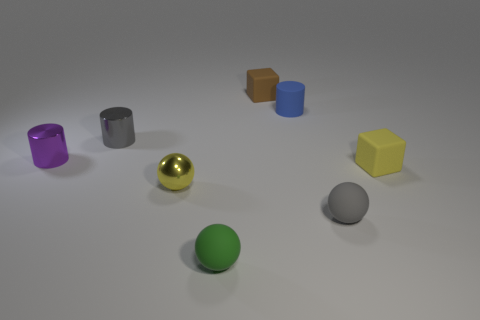Add 1 big purple objects. How many objects exist? 9 Subtract all cylinders. How many objects are left? 5 Add 1 big gray metallic spheres. How many big gray metallic spheres exist? 1 Subtract 1 gray spheres. How many objects are left? 7 Subtract all tiny brown rubber balls. Subtract all small blocks. How many objects are left? 6 Add 8 blue matte cylinders. How many blue matte cylinders are left? 9 